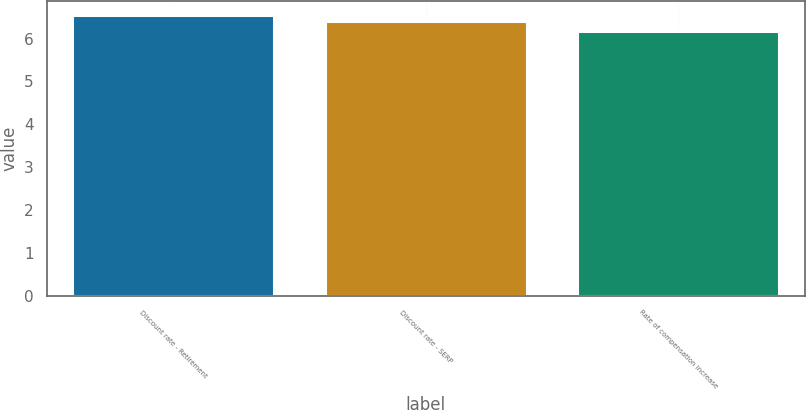<chart> <loc_0><loc_0><loc_500><loc_500><bar_chart><fcel>Discount rate - Retirement<fcel>Discount rate - SERP<fcel>Rate of compensation increase<nl><fcel>6.54<fcel>6.4<fcel>6.17<nl></chart> 